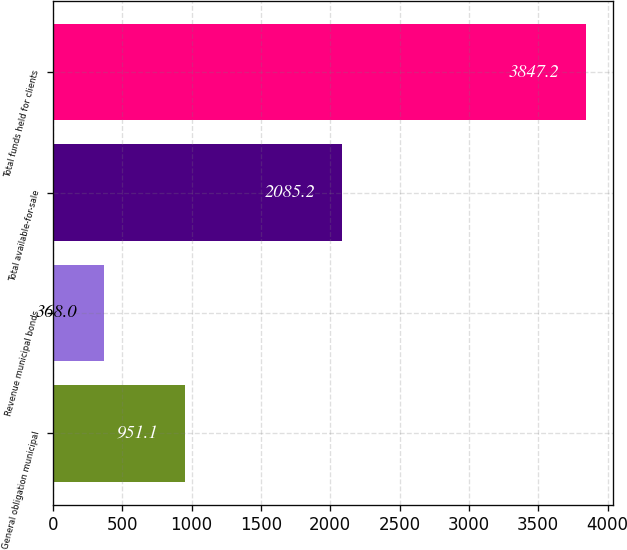Convert chart. <chart><loc_0><loc_0><loc_500><loc_500><bar_chart><fcel>General obligation municipal<fcel>Revenue municipal bonds<fcel>Total available-for-sale<fcel>Total funds held for clients<nl><fcel>951.1<fcel>368<fcel>2085.2<fcel>3847.2<nl></chart> 